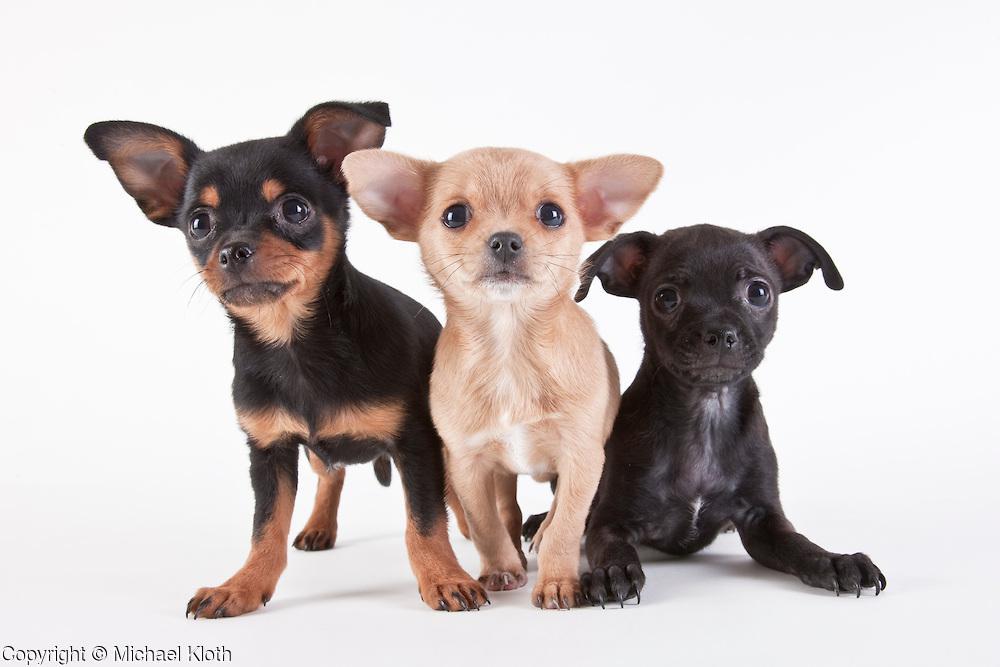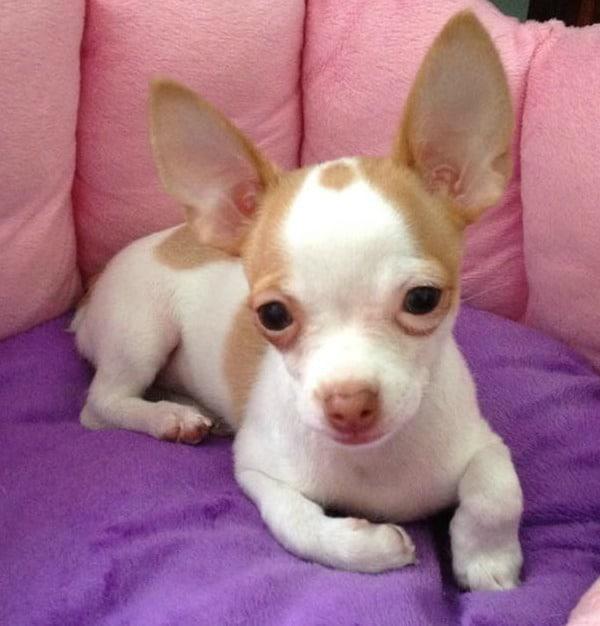The first image is the image on the left, the second image is the image on the right. Evaluate the accuracy of this statement regarding the images: "There are more dogs in the image on the right.". Is it true? Answer yes or no. No. The first image is the image on the left, the second image is the image on the right. For the images shown, is this caption "All chihuahuas pictured are wearing at least collars, and each image includes at least one standing chihuahua." true? Answer yes or no. No. 